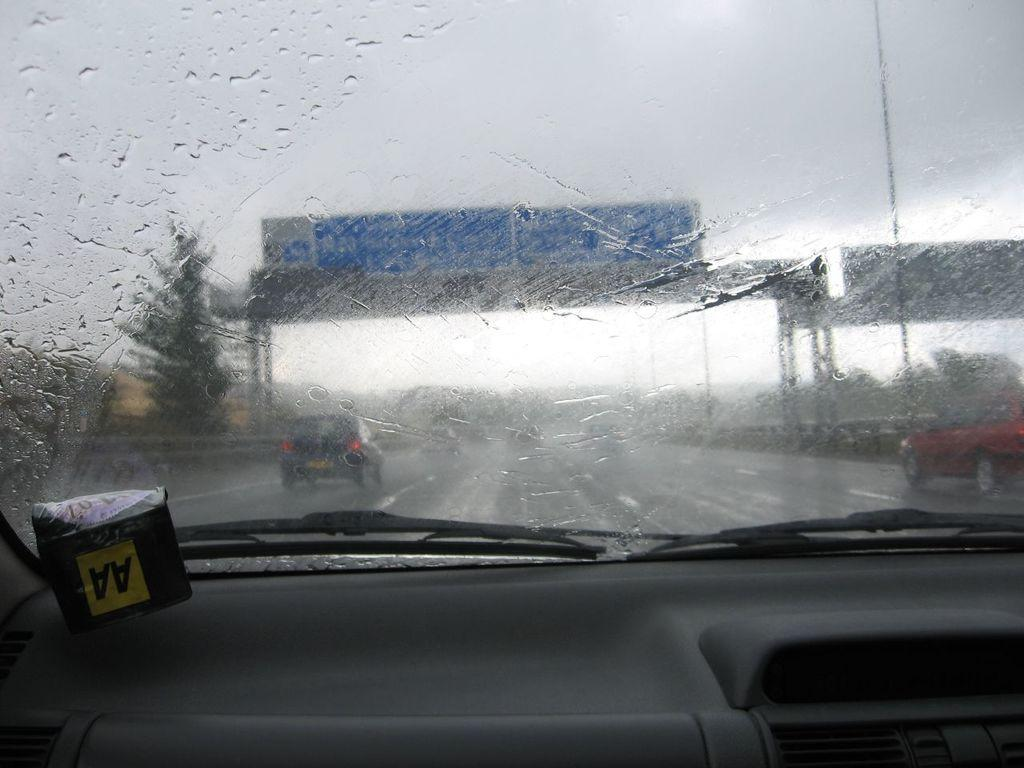Where was the image taken? The image was taken inside a car. What is the main subject of the image? There is a car at the center of the image. What can be seen outside the car in the image? There is a road visible in the image. What is present near the road in the image? There is a sign board in the image. What type of vegetation is visible at the left side of the image? There is a tree at the left side of the image. What is the grip of the tree in the image? The image does not provide information about the grip of the tree; it only shows the tree's presence at the left side of the image. 